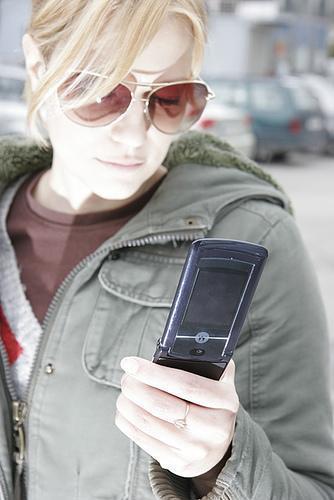How many cars are in the photo?
Give a very brief answer. 2. How many people are using backpacks or bags?
Give a very brief answer. 0. 